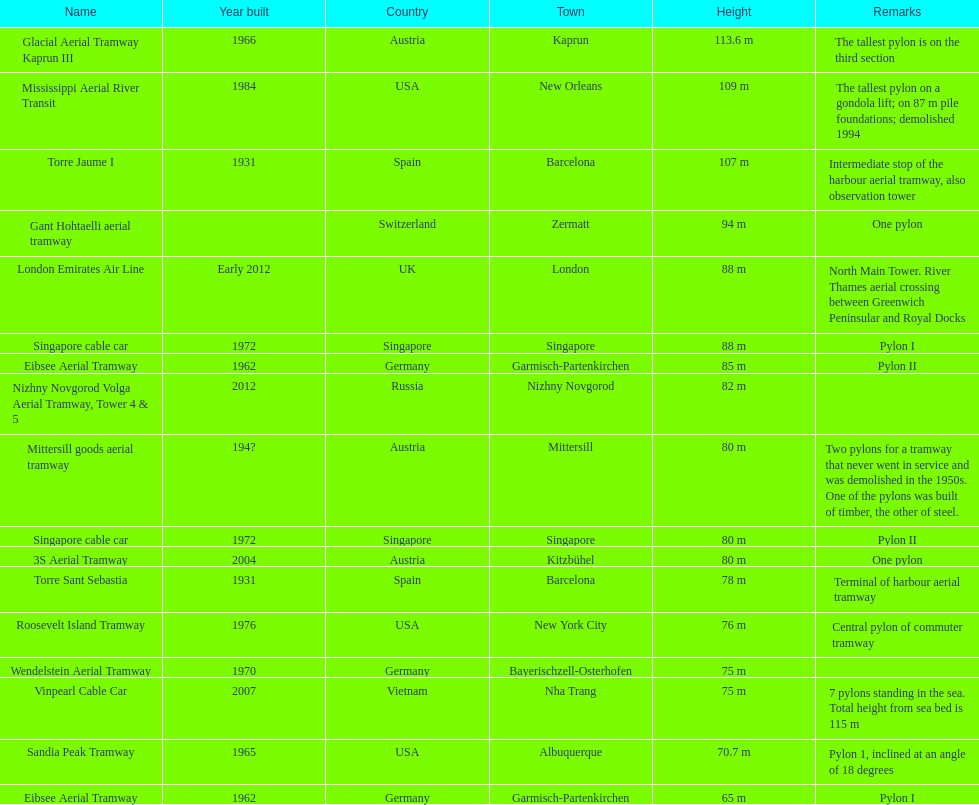What is the complete number of the tallest pylons in austria? 3. 